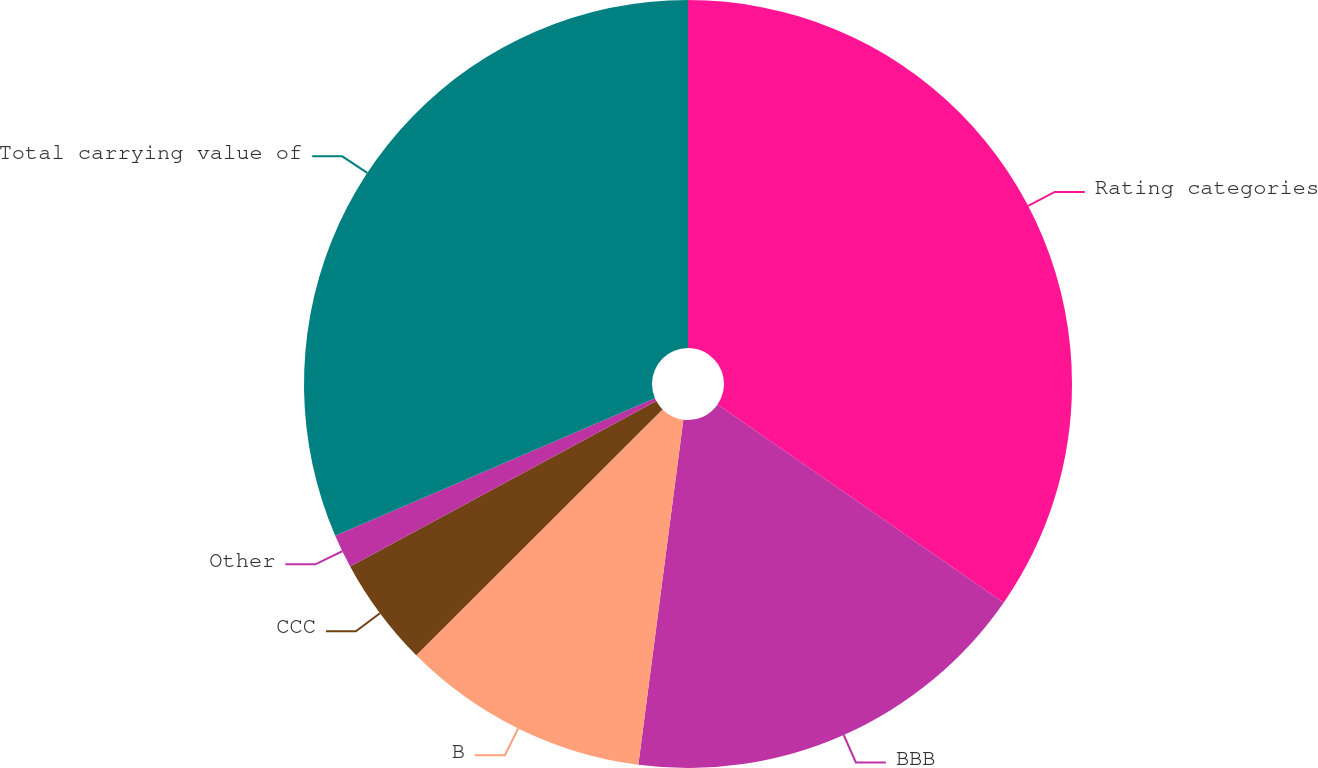<chart> <loc_0><loc_0><loc_500><loc_500><pie_chart><fcel>Rating categories<fcel>BBB<fcel>B<fcel>CCC<fcel>Other<fcel>Total carrying value of<nl><fcel>34.64%<fcel>17.42%<fcel>10.45%<fcel>4.6%<fcel>1.42%<fcel>31.46%<nl></chart> 